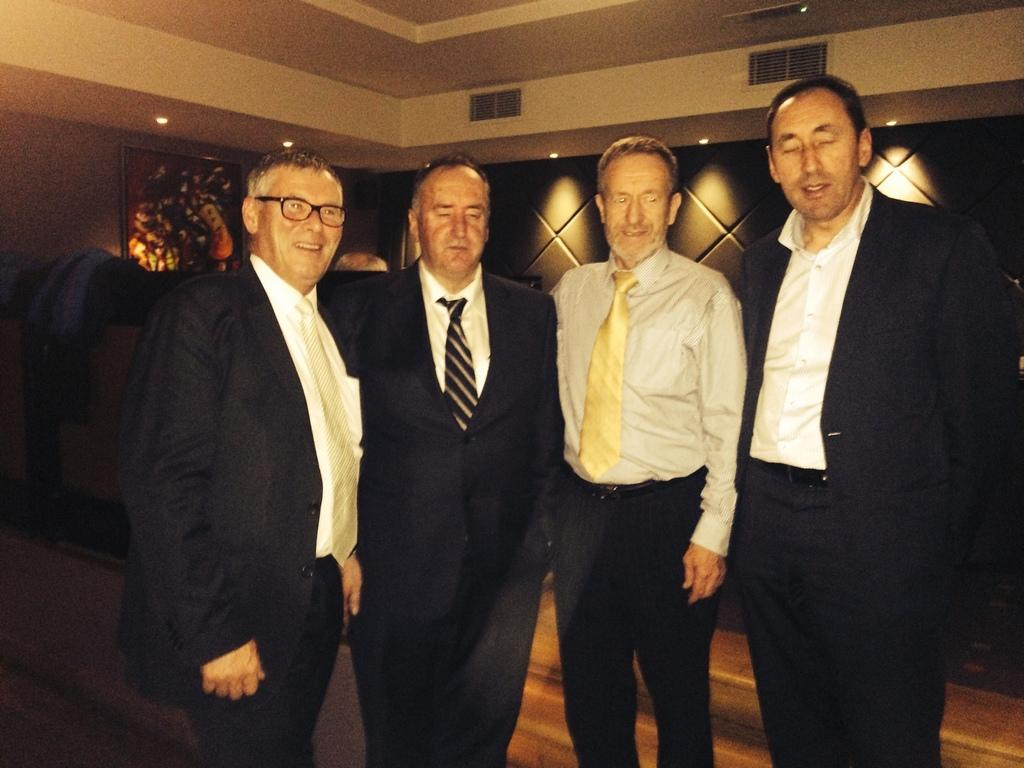What can be seen in the image? There are men standing in the image. What are the men wearing? The men are wearing suits. Where was the image taken? The image was taken inside a room. What is visible above the men in the image? There is a ceiling visible in the image, and lights are on the ceiling. What type of thread is being used to stitch the wound on the man's arm in the image? There is no mention of a wound or thread in the image; it only describes men standing in suits inside a room with a visible ceiling and lights. 